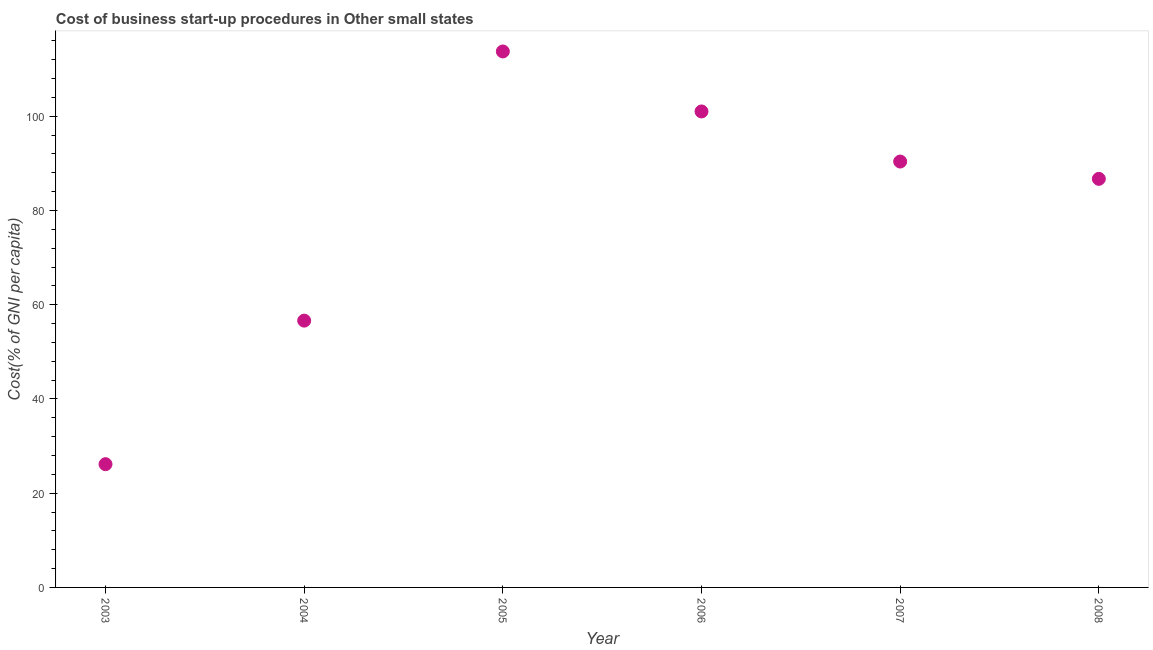What is the cost of business startup procedures in 2008?
Provide a short and direct response. 86.72. Across all years, what is the maximum cost of business startup procedures?
Your response must be concise. 113.75. Across all years, what is the minimum cost of business startup procedures?
Provide a short and direct response. 26.16. In which year was the cost of business startup procedures maximum?
Make the answer very short. 2005. What is the sum of the cost of business startup procedures?
Ensure brevity in your answer.  474.67. What is the difference between the cost of business startup procedures in 2007 and 2008?
Provide a short and direct response. 3.67. What is the average cost of business startup procedures per year?
Ensure brevity in your answer.  79.11. What is the median cost of business startup procedures?
Provide a short and direct response. 88.55. Do a majority of the years between 2006 and 2004 (inclusive) have cost of business startup procedures greater than 32 %?
Give a very brief answer. No. What is the ratio of the cost of business startup procedures in 2006 to that in 2007?
Your answer should be very brief. 1.12. What is the difference between the highest and the second highest cost of business startup procedures?
Offer a terse response. 12.73. What is the difference between the highest and the lowest cost of business startup procedures?
Make the answer very short. 87.59. Does the cost of business startup procedures monotonically increase over the years?
Offer a terse response. No. How many dotlines are there?
Make the answer very short. 1. How many years are there in the graph?
Make the answer very short. 6. Are the values on the major ticks of Y-axis written in scientific E-notation?
Provide a succinct answer. No. Does the graph contain any zero values?
Make the answer very short. No. What is the title of the graph?
Provide a succinct answer. Cost of business start-up procedures in Other small states. What is the label or title of the Y-axis?
Your response must be concise. Cost(% of GNI per capita). What is the Cost(% of GNI per capita) in 2003?
Make the answer very short. 26.16. What is the Cost(% of GNI per capita) in 2004?
Keep it short and to the point. 56.62. What is the Cost(% of GNI per capita) in 2005?
Your response must be concise. 113.75. What is the Cost(% of GNI per capita) in 2006?
Keep it short and to the point. 101.02. What is the Cost(% of GNI per capita) in 2007?
Give a very brief answer. 90.39. What is the Cost(% of GNI per capita) in 2008?
Provide a short and direct response. 86.72. What is the difference between the Cost(% of GNI per capita) in 2003 and 2004?
Offer a terse response. -30.46. What is the difference between the Cost(% of GNI per capita) in 2003 and 2005?
Your answer should be very brief. -87.59. What is the difference between the Cost(% of GNI per capita) in 2003 and 2006?
Offer a very short reply. -74.86. What is the difference between the Cost(% of GNI per capita) in 2003 and 2007?
Your answer should be very brief. -64.23. What is the difference between the Cost(% of GNI per capita) in 2003 and 2008?
Keep it short and to the point. -60.56. What is the difference between the Cost(% of GNI per capita) in 2004 and 2005?
Your answer should be compact. -57.13. What is the difference between the Cost(% of GNI per capita) in 2004 and 2006?
Give a very brief answer. -44.4. What is the difference between the Cost(% of GNI per capita) in 2004 and 2007?
Give a very brief answer. -33.76. What is the difference between the Cost(% of GNI per capita) in 2004 and 2008?
Keep it short and to the point. -30.09. What is the difference between the Cost(% of GNI per capita) in 2005 and 2006?
Give a very brief answer. 12.73. What is the difference between the Cost(% of GNI per capita) in 2005 and 2007?
Keep it short and to the point. 23.36. What is the difference between the Cost(% of GNI per capita) in 2005 and 2008?
Your response must be concise. 27.04. What is the difference between the Cost(% of GNI per capita) in 2006 and 2007?
Make the answer very short. 10.63. What is the difference between the Cost(% of GNI per capita) in 2006 and 2008?
Keep it short and to the point. 14.31. What is the difference between the Cost(% of GNI per capita) in 2007 and 2008?
Give a very brief answer. 3.67. What is the ratio of the Cost(% of GNI per capita) in 2003 to that in 2004?
Give a very brief answer. 0.46. What is the ratio of the Cost(% of GNI per capita) in 2003 to that in 2005?
Provide a succinct answer. 0.23. What is the ratio of the Cost(% of GNI per capita) in 2003 to that in 2006?
Your answer should be very brief. 0.26. What is the ratio of the Cost(% of GNI per capita) in 2003 to that in 2007?
Provide a succinct answer. 0.29. What is the ratio of the Cost(% of GNI per capita) in 2003 to that in 2008?
Your answer should be very brief. 0.3. What is the ratio of the Cost(% of GNI per capita) in 2004 to that in 2005?
Offer a terse response. 0.5. What is the ratio of the Cost(% of GNI per capita) in 2004 to that in 2006?
Offer a terse response. 0.56. What is the ratio of the Cost(% of GNI per capita) in 2004 to that in 2007?
Keep it short and to the point. 0.63. What is the ratio of the Cost(% of GNI per capita) in 2004 to that in 2008?
Make the answer very short. 0.65. What is the ratio of the Cost(% of GNI per capita) in 2005 to that in 2006?
Your response must be concise. 1.13. What is the ratio of the Cost(% of GNI per capita) in 2005 to that in 2007?
Give a very brief answer. 1.26. What is the ratio of the Cost(% of GNI per capita) in 2005 to that in 2008?
Provide a succinct answer. 1.31. What is the ratio of the Cost(% of GNI per capita) in 2006 to that in 2007?
Make the answer very short. 1.12. What is the ratio of the Cost(% of GNI per capita) in 2006 to that in 2008?
Your answer should be compact. 1.17. What is the ratio of the Cost(% of GNI per capita) in 2007 to that in 2008?
Your answer should be very brief. 1.04. 